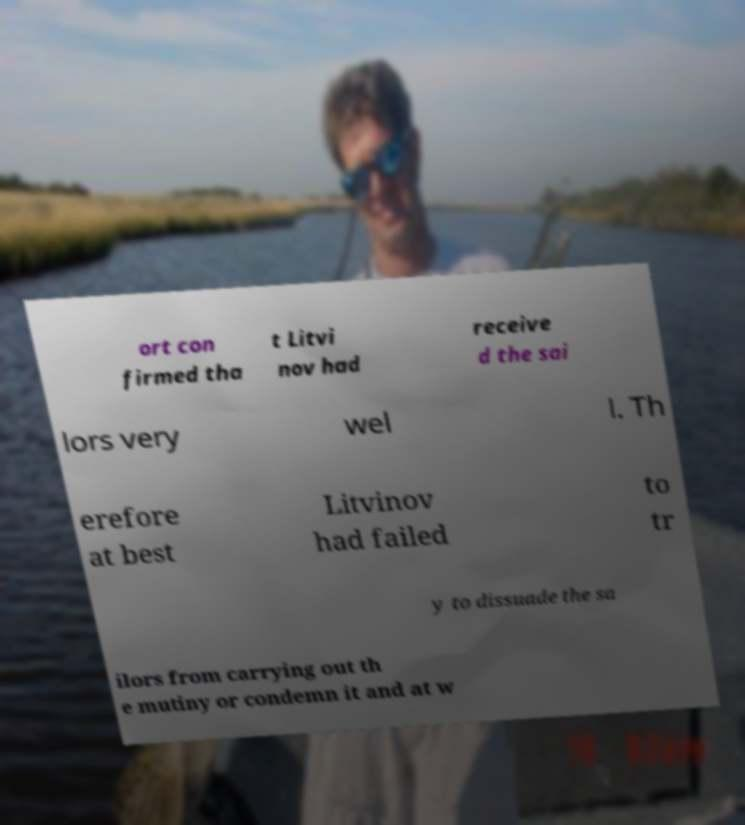What messages or text are displayed in this image? I need them in a readable, typed format. ort con firmed tha t Litvi nov had receive d the sai lors very wel l. Th erefore at best Litvinov had failed to tr y to dissuade the sa ilors from carrying out th e mutiny or condemn it and at w 